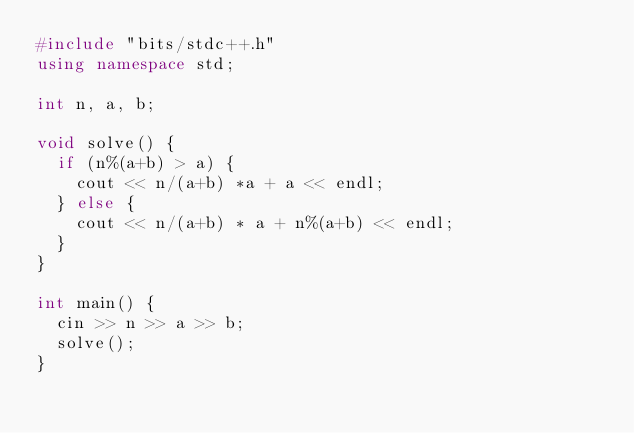Convert code to text. <code><loc_0><loc_0><loc_500><loc_500><_C++_>#include "bits/stdc++.h"
using namespace std;

int n, a, b;

void solve() {
  if (n%(a+b) > a) {
    cout << n/(a+b) *a + a << endl;
  } else {
    cout << n/(a+b) * a + n%(a+b) << endl;
  }
}

int main() {
  cin >> n >> a >> b;
  solve();
}</code> 